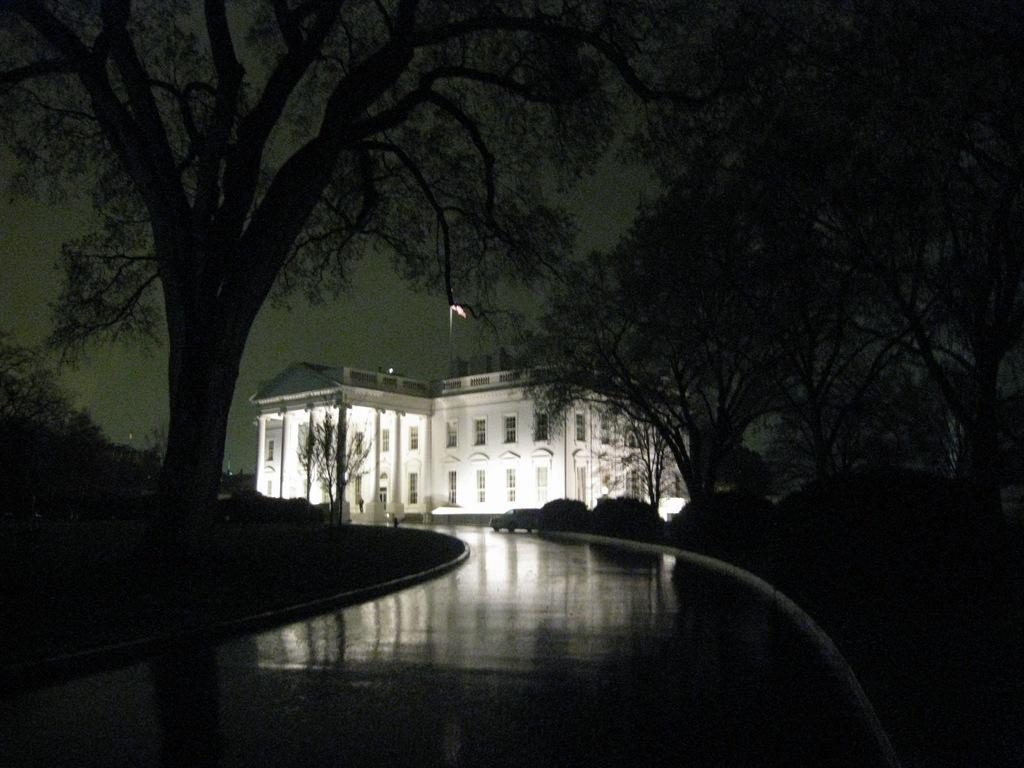How would you summarize this image in a sentence or two? In this image I can see number of trees, a white colour building and I can see this image is little bit in dark. 